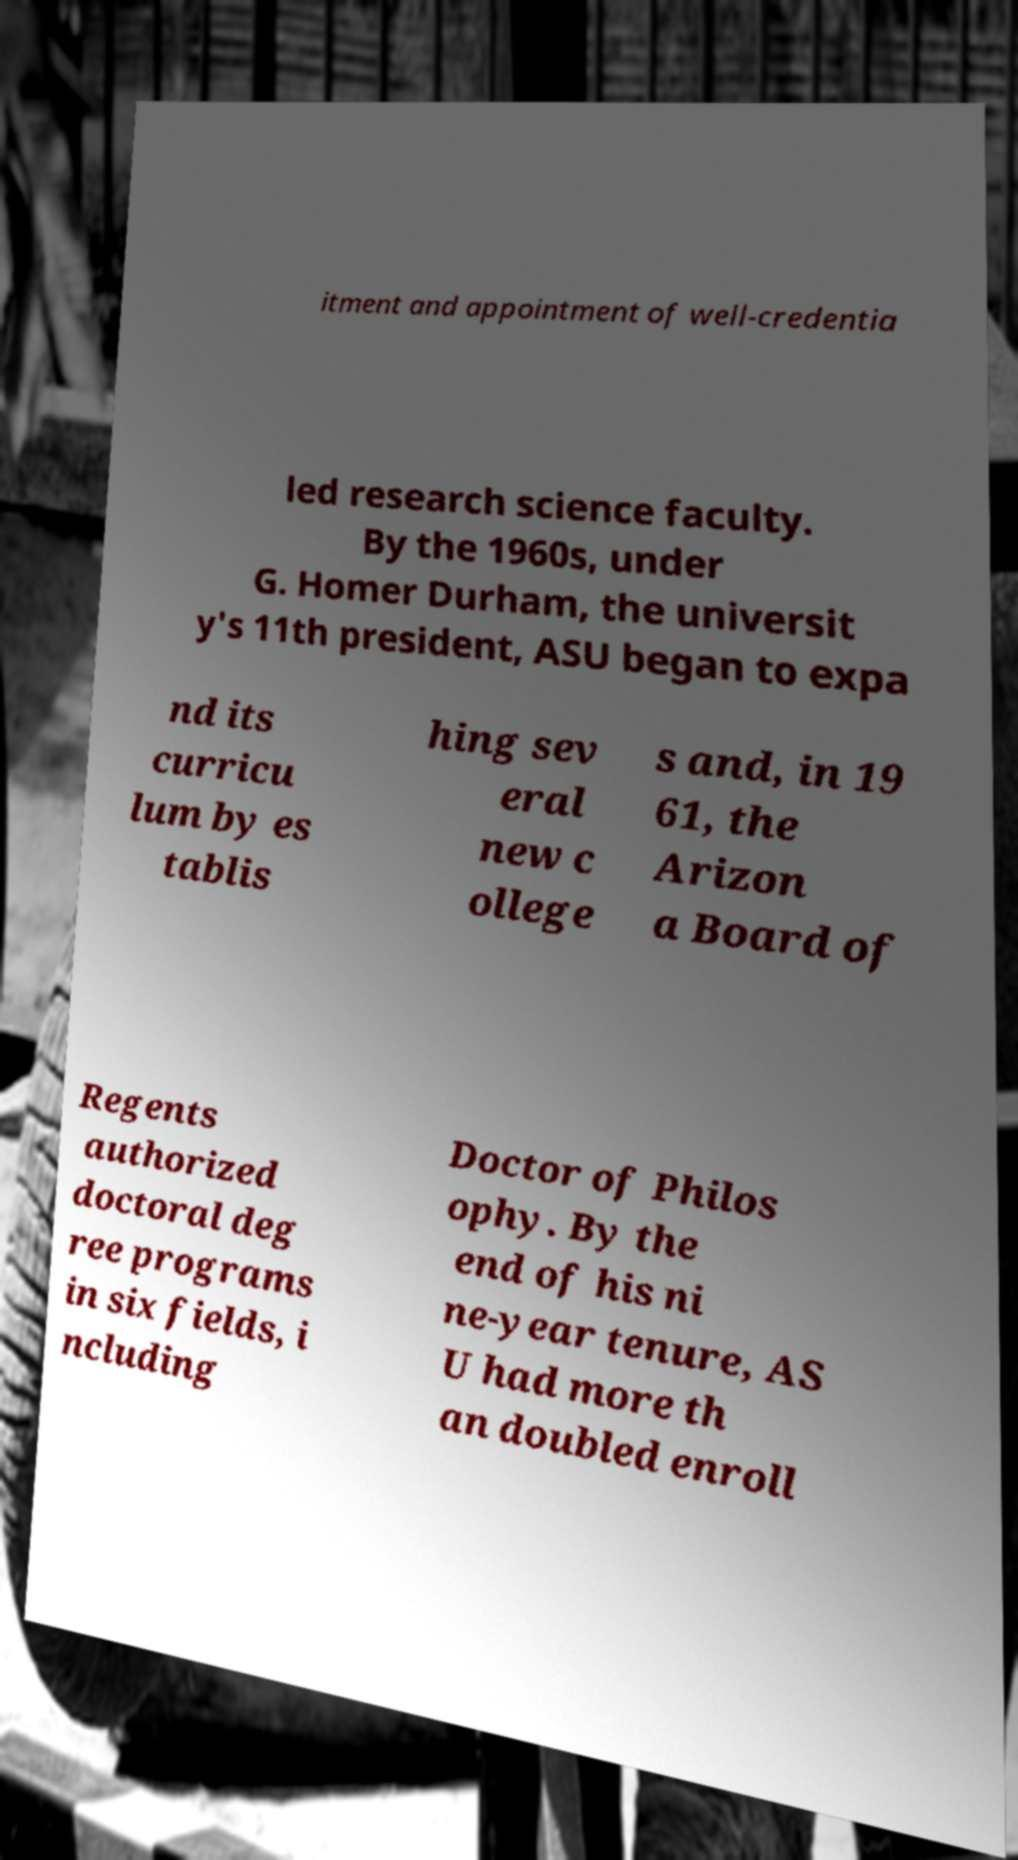Could you assist in decoding the text presented in this image and type it out clearly? itment and appointment of well-credentia led research science faculty. By the 1960s, under G. Homer Durham, the universit y's 11th president, ASU began to expa nd its curricu lum by es tablis hing sev eral new c ollege s and, in 19 61, the Arizon a Board of Regents authorized doctoral deg ree programs in six fields, i ncluding Doctor of Philos ophy. By the end of his ni ne-year tenure, AS U had more th an doubled enroll 